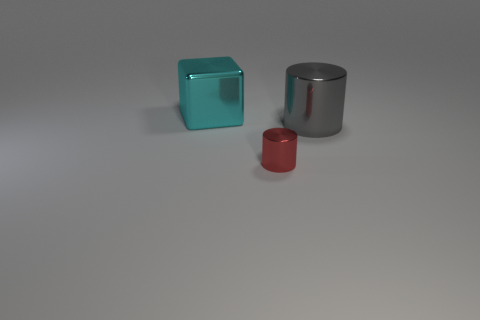Are there any indications about the function or purpose of these objects from the image? There are no immediate indicators of the objects' functions in the image; they appear as geometric shapes likely presented for aesthetic or illustrative purposes, rather than practical use. Could the size and proportion of these objects tell us something about their context or setting? The size and proportion of these objects, particularly the small scale of the red cylinder compared to the larger cyan cube and silver cylinder, could suggest they are part of a display or some artistic arrangement, meant for observation rather than operation. 